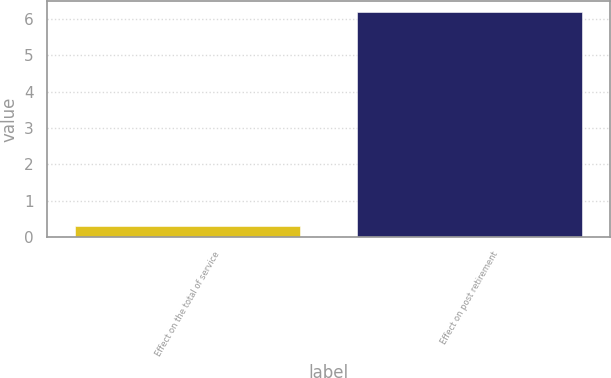<chart> <loc_0><loc_0><loc_500><loc_500><bar_chart><fcel>Effect on the total of service<fcel>Effect on post retirement<nl><fcel>0.3<fcel>6.2<nl></chart> 